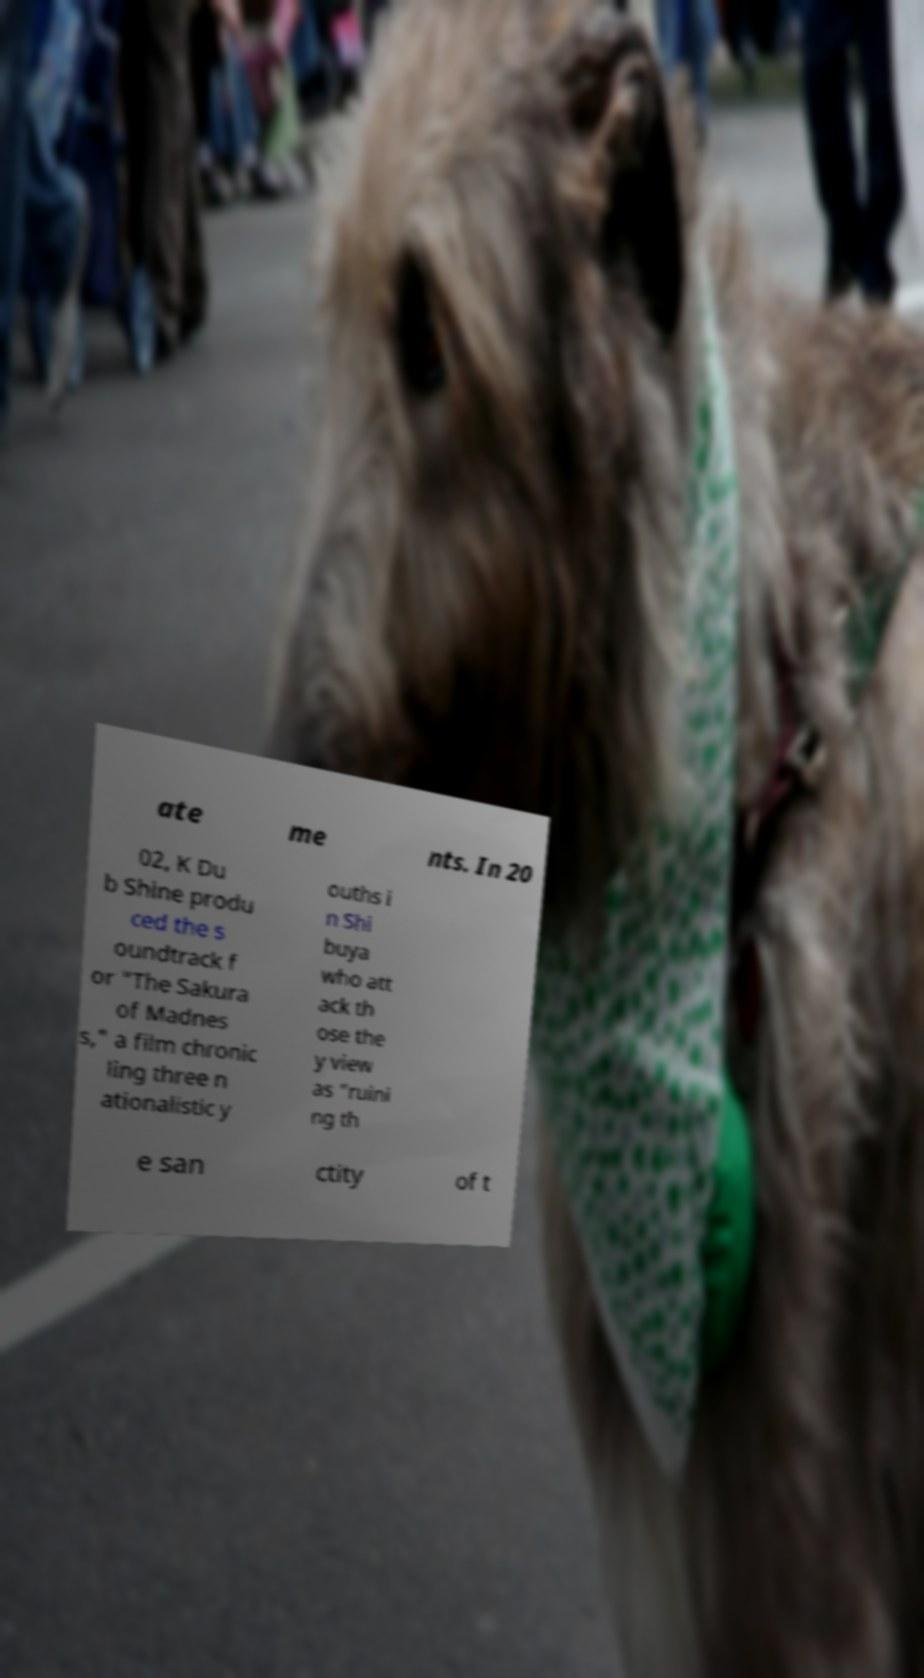There's text embedded in this image that I need extracted. Can you transcribe it verbatim? ate me nts. In 20 02, K Du b Shine produ ced the s oundtrack f or "The Sakura of Madnes s," a film chronic ling three n ationalistic y ouths i n Shi buya who att ack th ose the y view as “ruini ng th e san ctity of t 